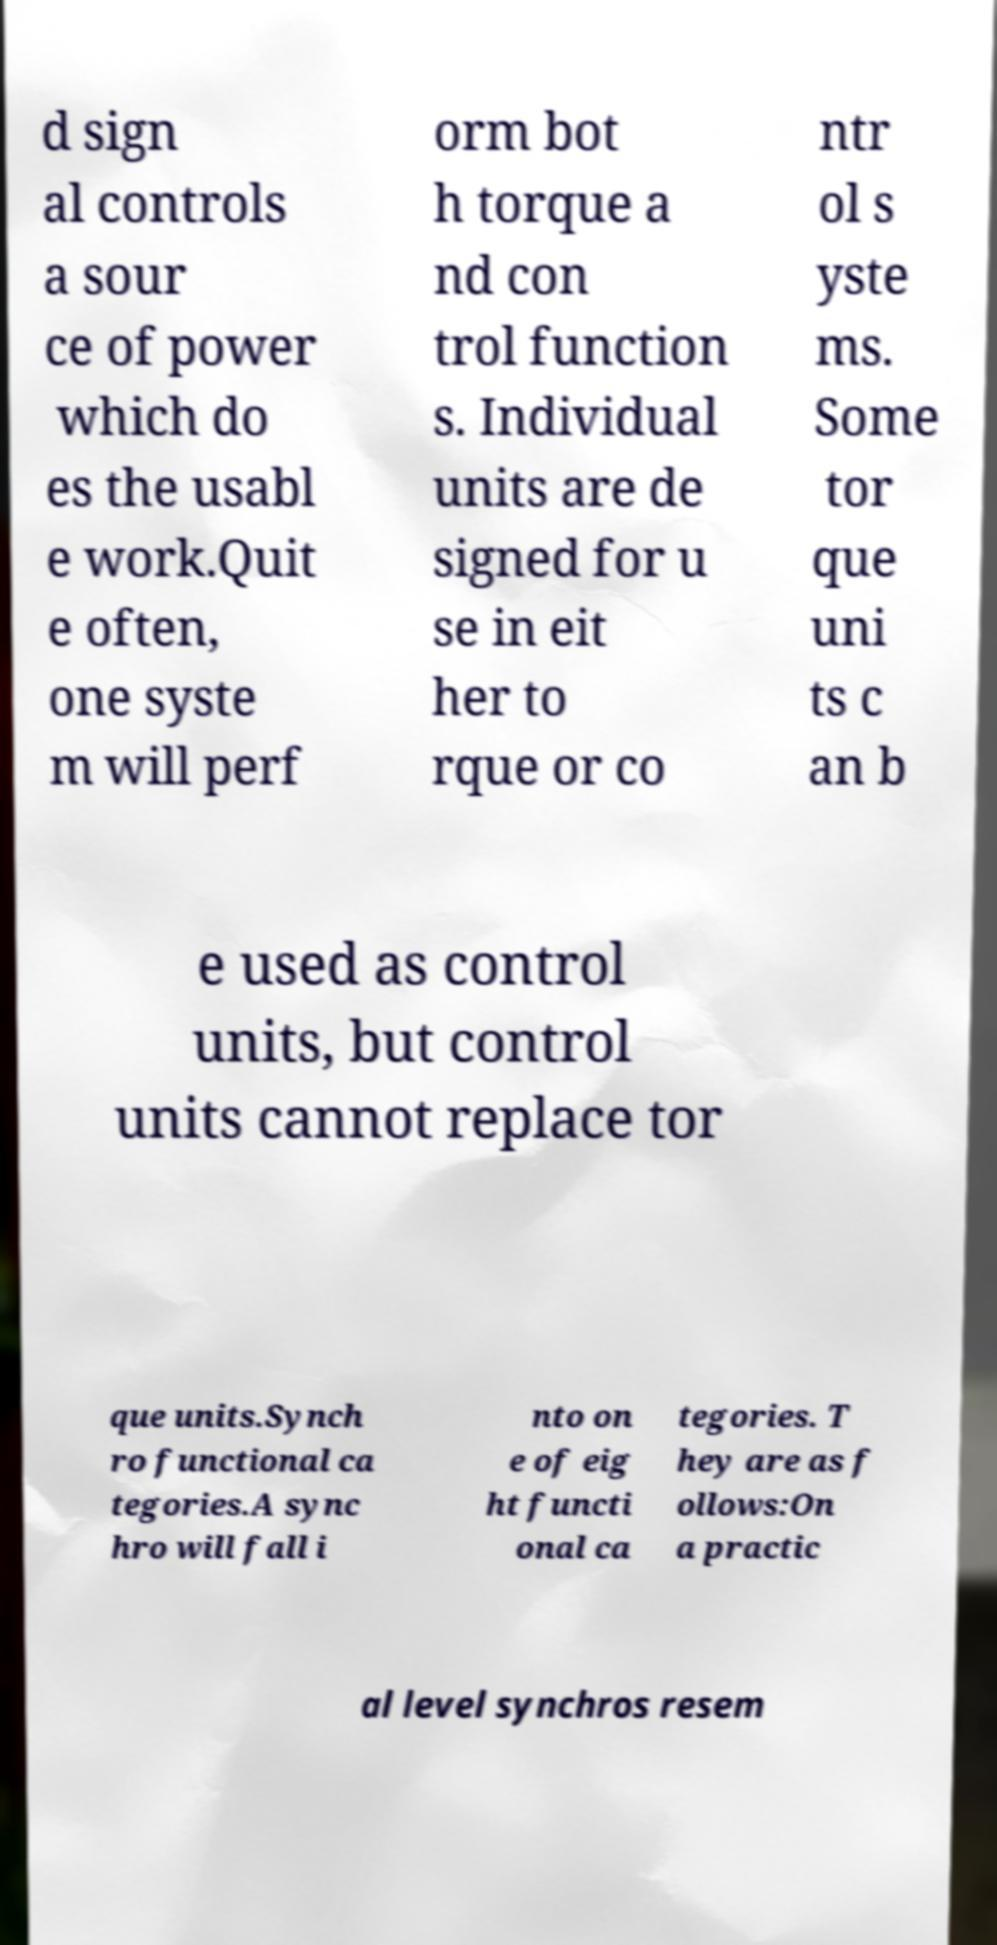There's text embedded in this image that I need extracted. Can you transcribe it verbatim? d sign al controls a sour ce of power which do es the usabl e work.Quit e often, one syste m will perf orm bot h torque a nd con trol function s. Individual units are de signed for u se in eit her to rque or co ntr ol s yste ms. Some tor que uni ts c an b e used as control units, but control units cannot replace tor que units.Synch ro functional ca tegories.A sync hro will fall i nto on e of eig ht functi onal ca tegories. T hey are as f ollows:On a practic al level synchros resem 